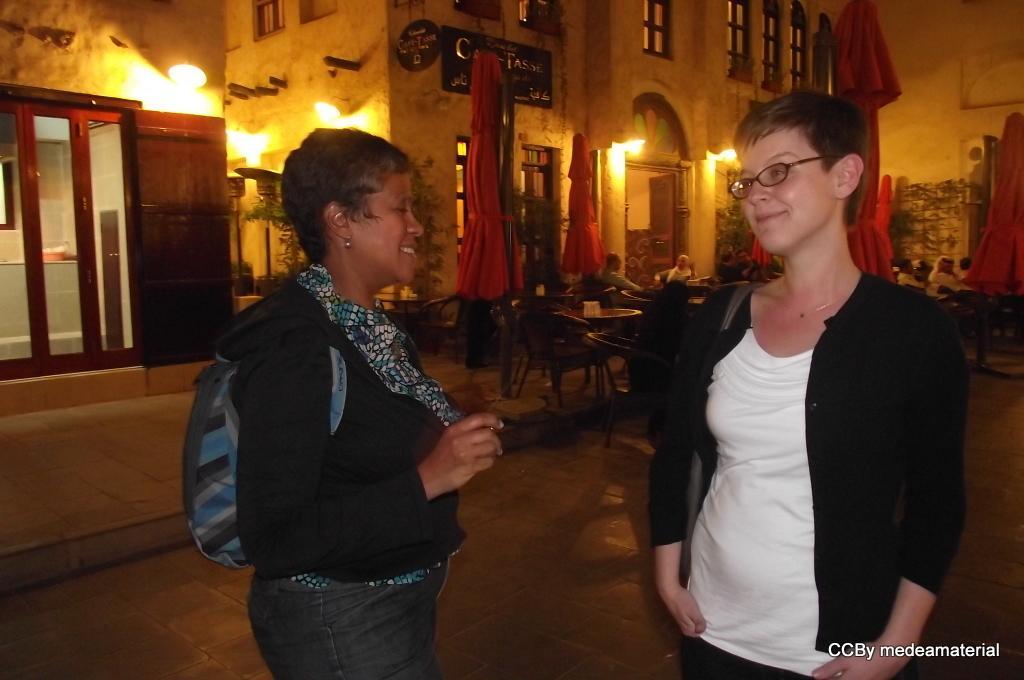How would you summarize this image in a sentence or two? In this image I can see two persons standing. The person at right wearing white and black shirt, at left the person wearing black shirt, blue bag. At back I can see few other persons sitting curtain in red color and a building. 